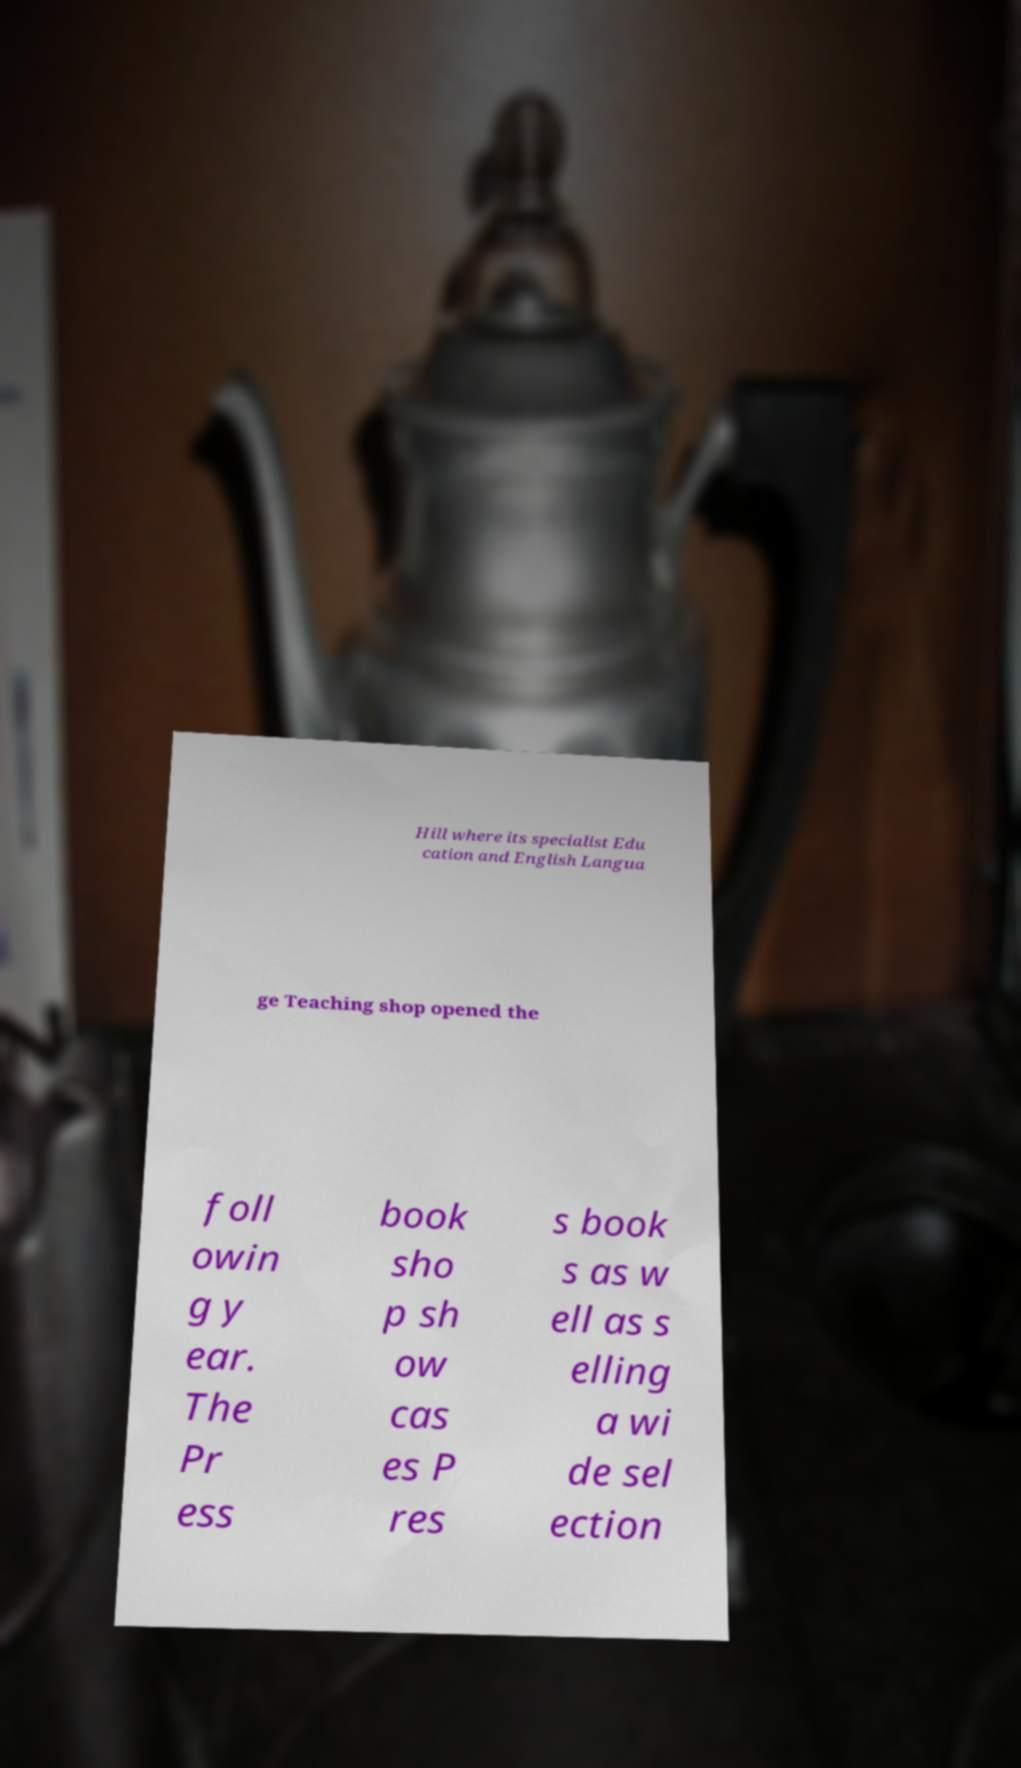Could you extract and type out the text from this image? Hill where its specialist Edu cation and English Langua ge Teaching shop opened the foll owin g y ear. The Pr ess book sho p sh ow cas es P res s book s as w ell as s elling a wi de sel ection 